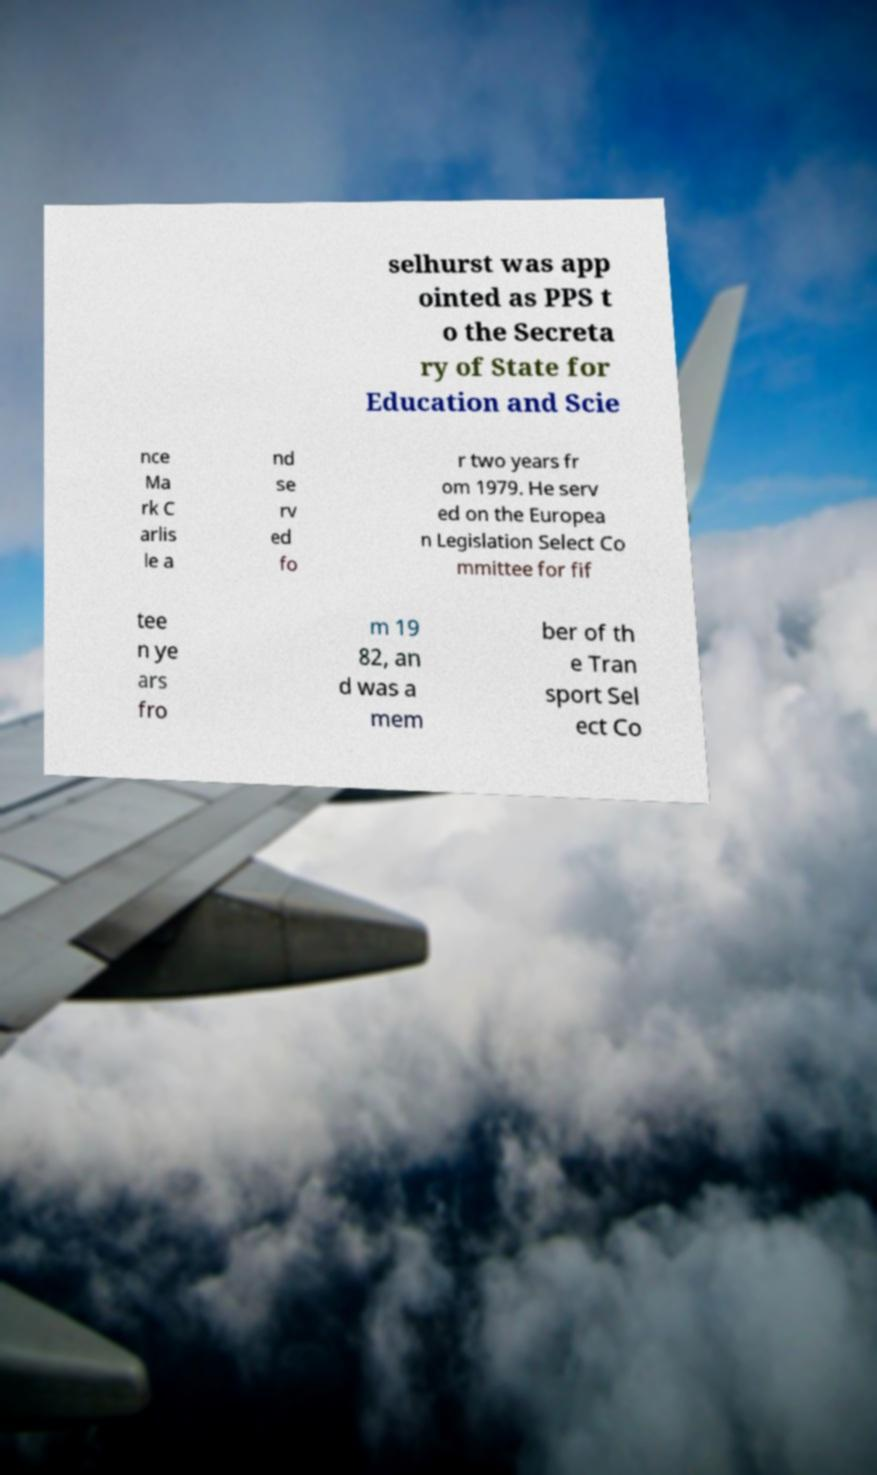Could you extract and type out the text from this image? selhurst was app ointed as PPS t o the Secreta ry of State for Education and Scie nce Ma rk C arlis le a nd se rv ed fo r two years fr om 1979. He serv ed on the Europea n Legislation Select Co mmittee for fif tee n ye ars fro m 19 82, an d was a mem ber of th e Tran sport Sel ect Co 